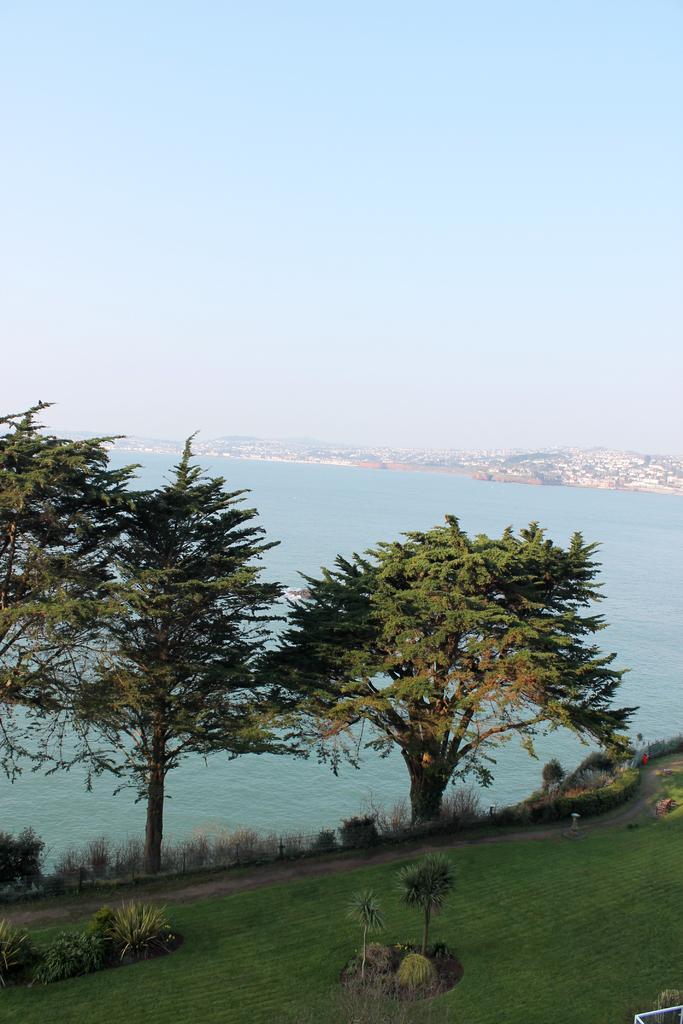How would you summarize this image in a sentence or two? In this image we can see the trees, plants, grass and also the sea. We can also see the buildings in the background. Sky is also visible. 